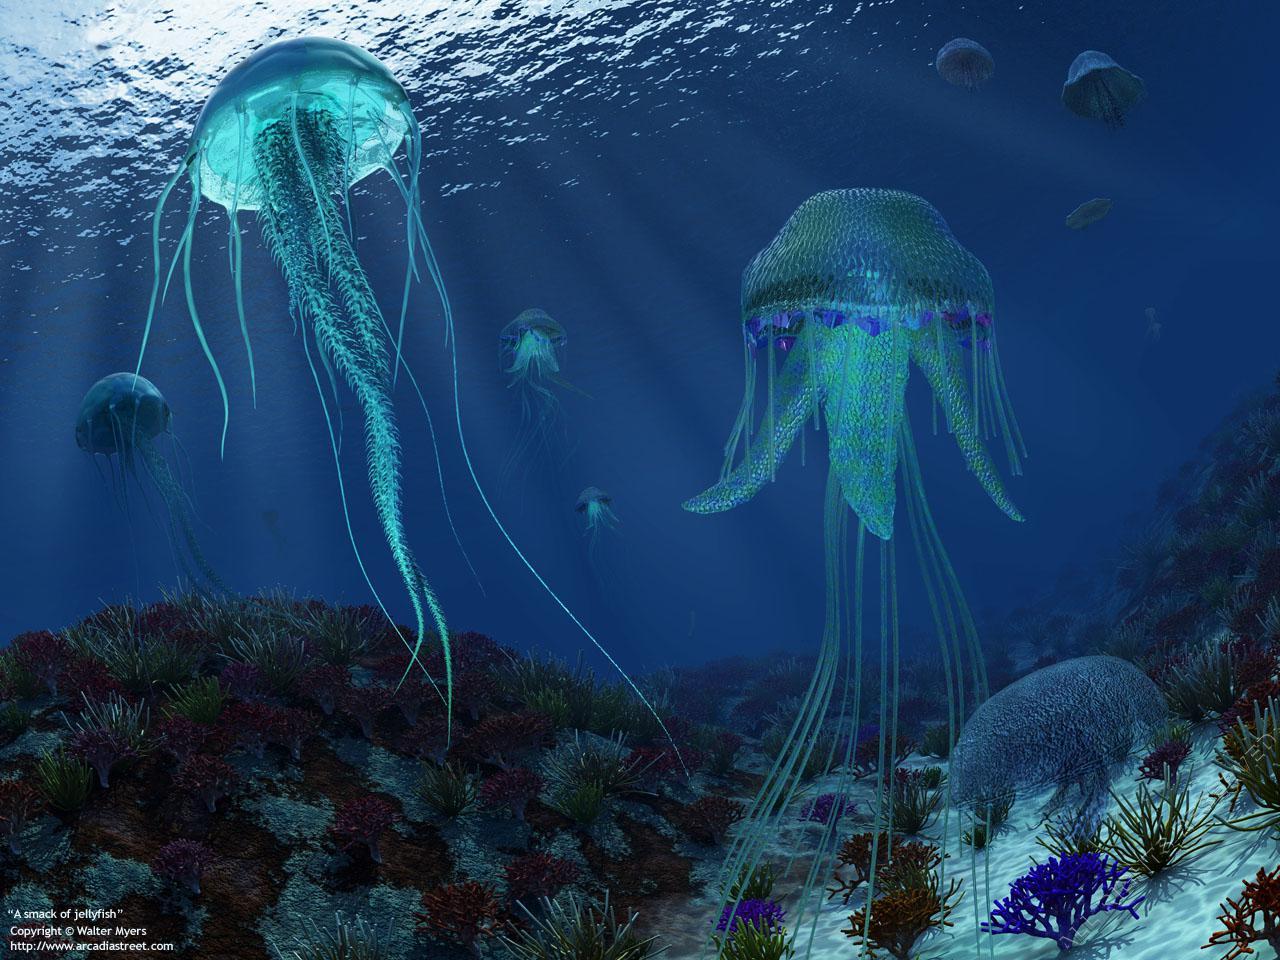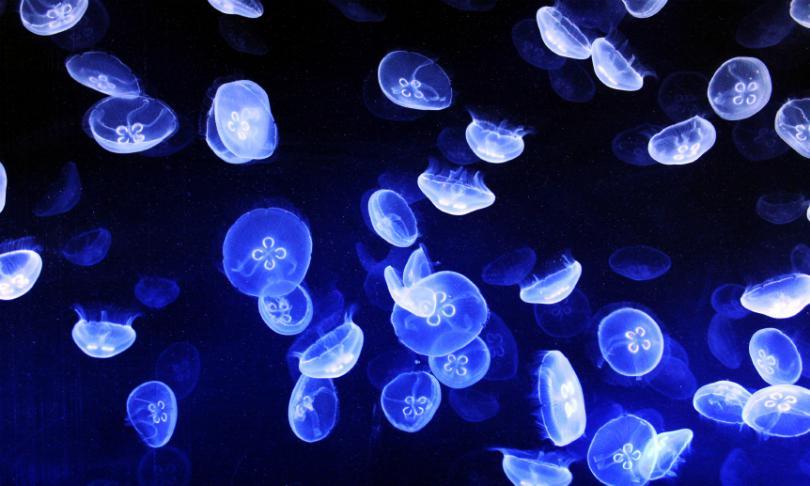The first image is the image on the left, the second image is the image on the right. For the images shown, is this caption "At least one image shows jellyfish of different colors." true? Answer yes or no. No. 